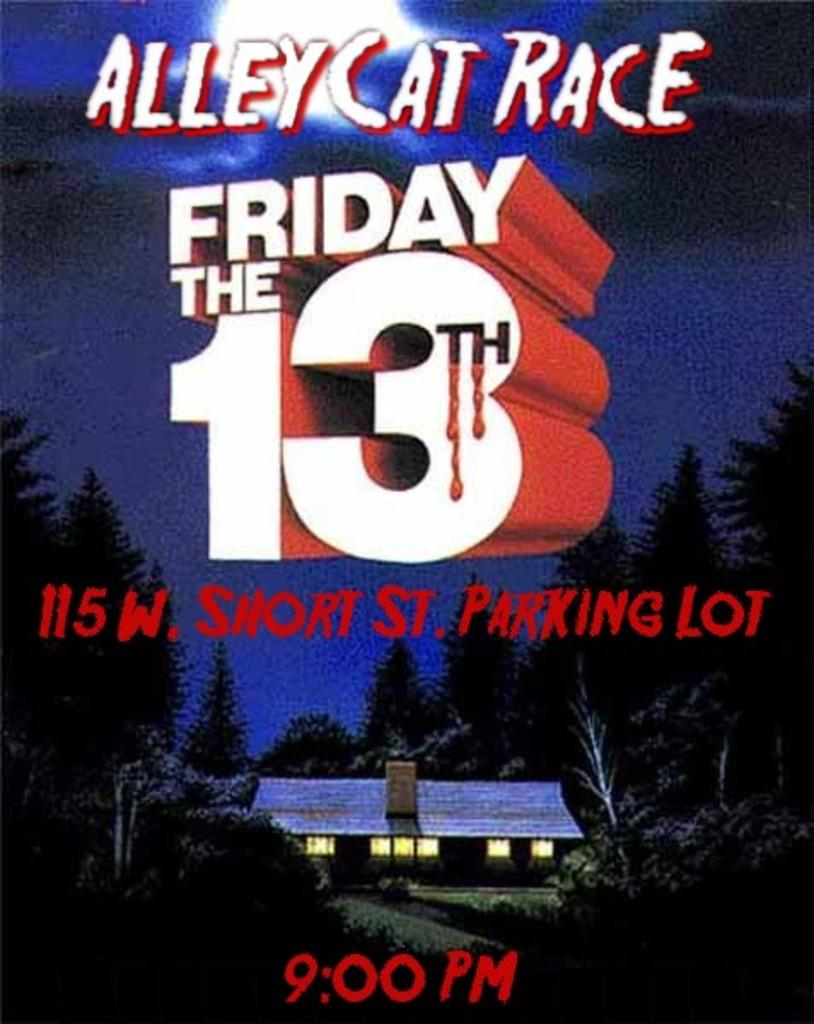<image>
Render a clear and concise summary of the photo. Poster for the Alley Cat Race which takes place on Friday the 13th. 